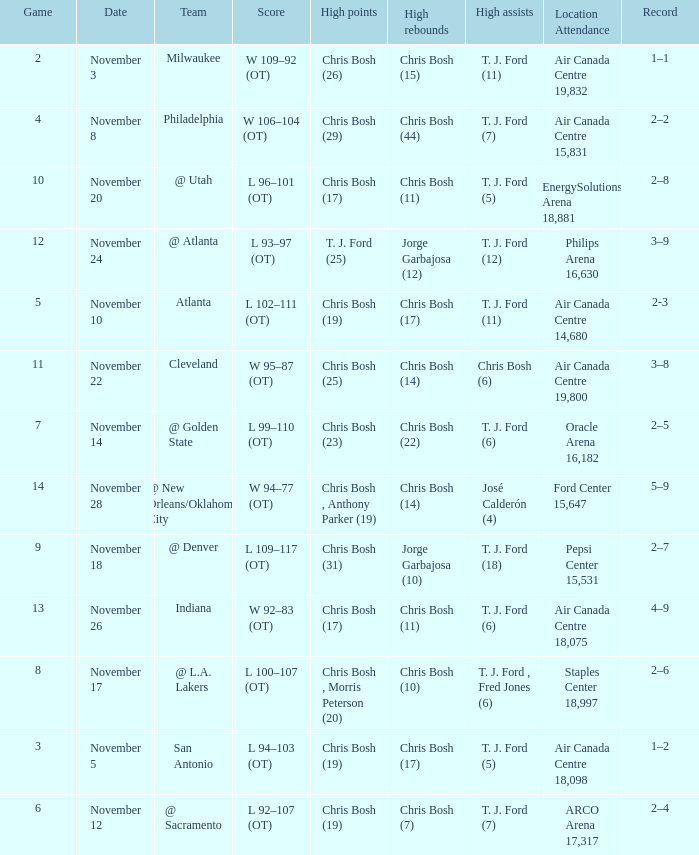What was the score of the game on November 12? L 92–107 (OT). 